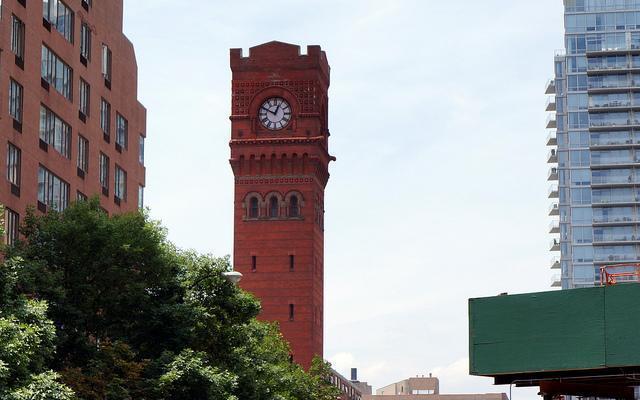How many arched windows under the clock?
Give a very brief answer. 3. 